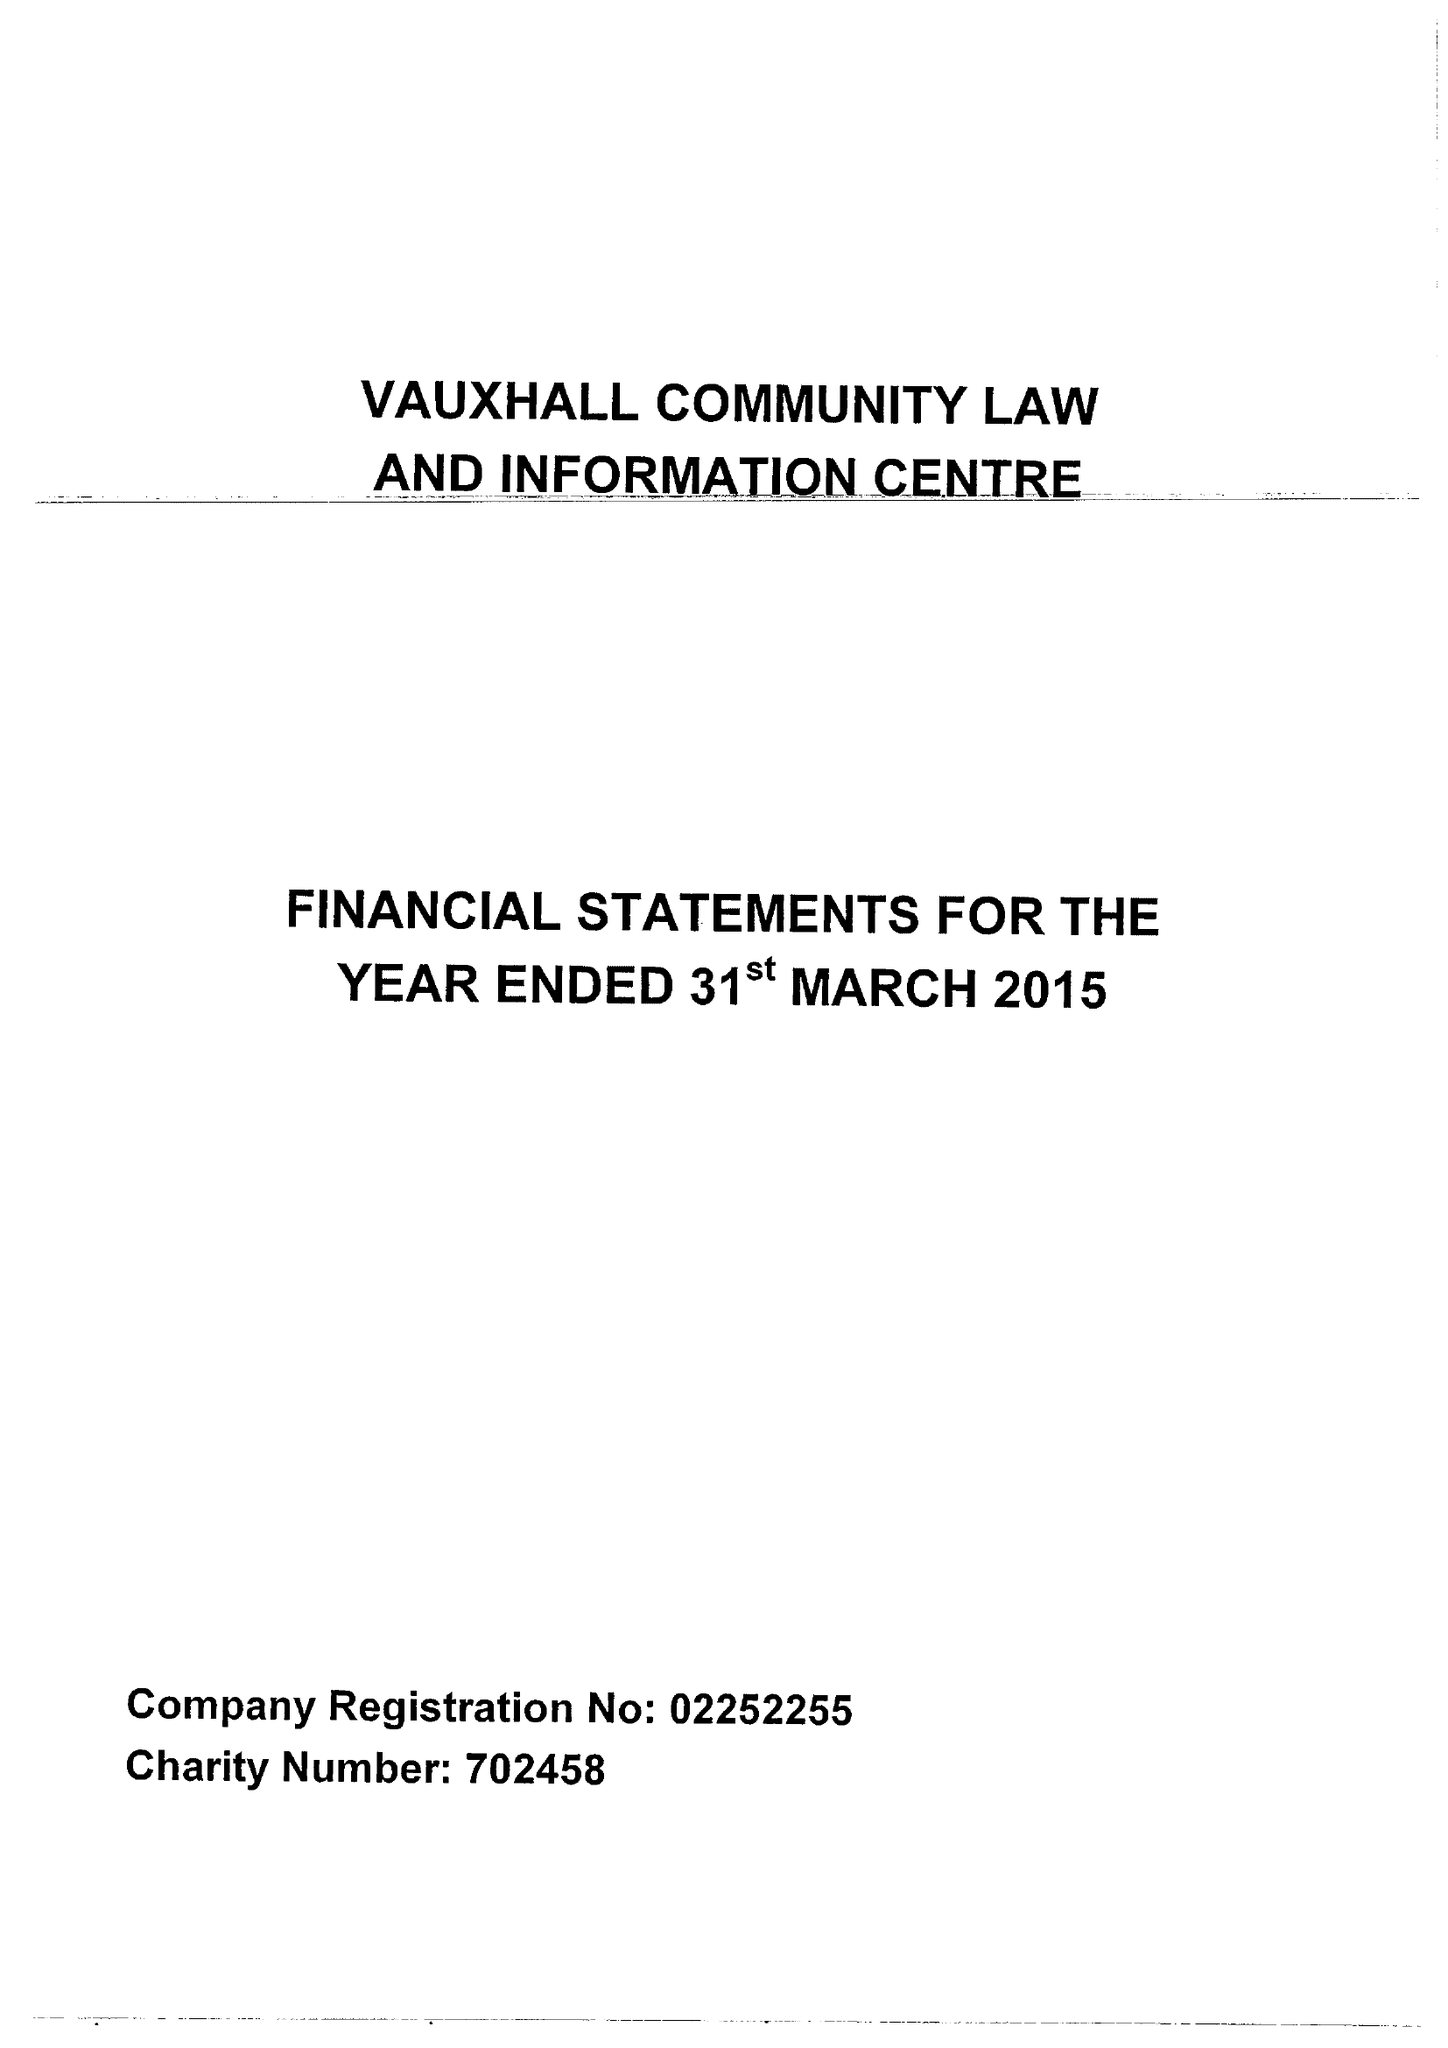What is the value for the address__postcode?
Answer the question using a single word or phrase. L5 8UX 